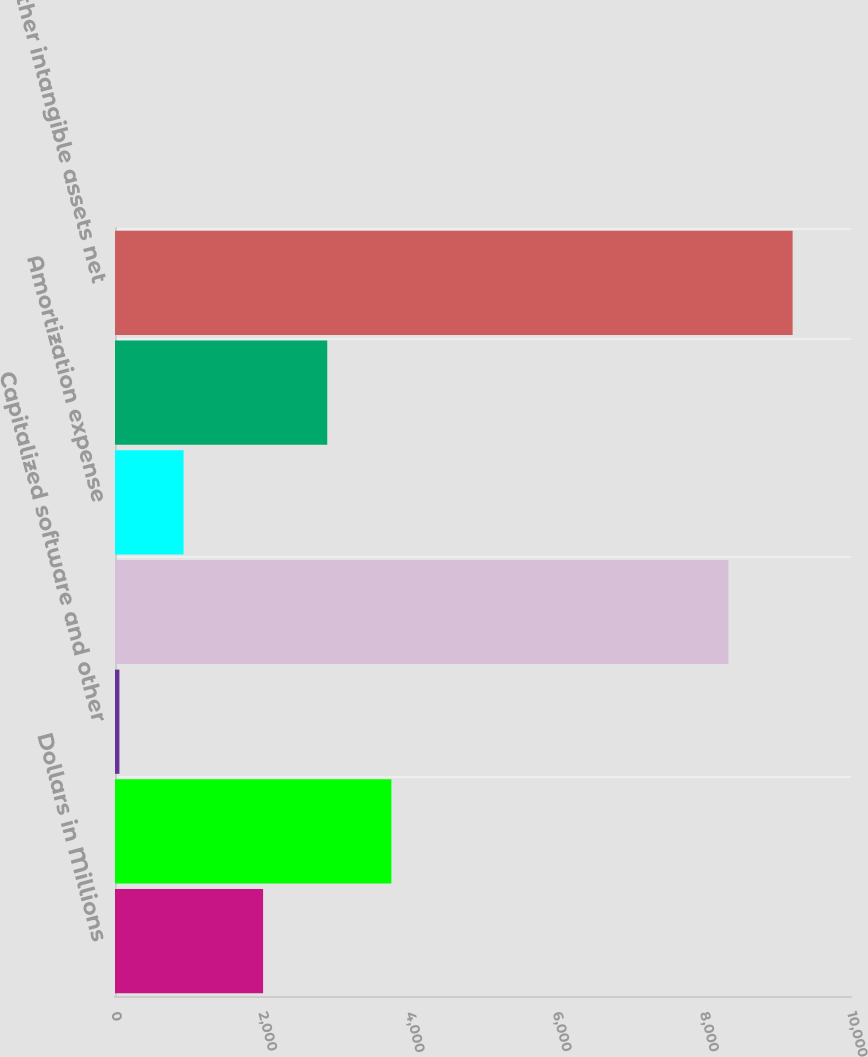<chart> <loc_0><loc_0><loc_500><loc_500><bar_chart><fcel>Dollars in Millions<fcel>Other intangible assets<fcel>Capitalized software and other<fcel>Acquisitions<fcel>Amortization expense<fcel>Impairment charges<fcel>Other intangible assets net<nl><fcel>2012<fcel>3755.6<fcel>60<fcel>8335<fcel>931.8<fcel>2883.8<fcel>9206.8<nl></chart> 